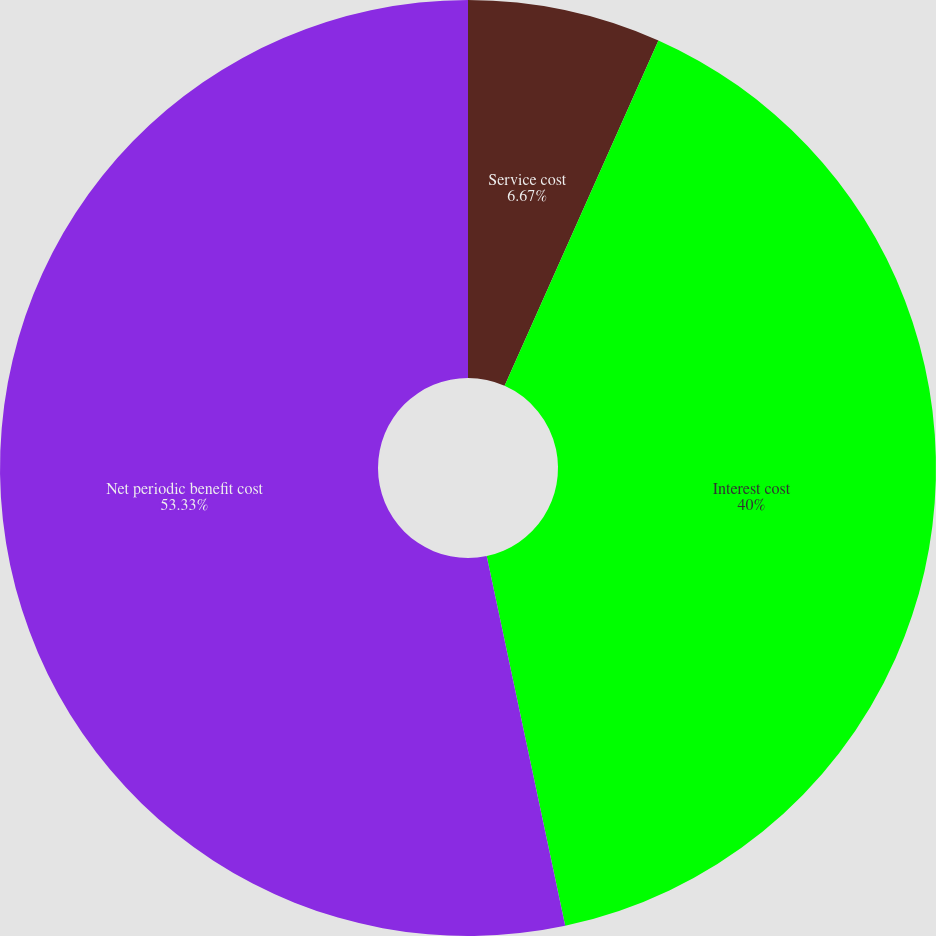Convert chart to OTSL. <chart><loc_0><loc_0><loc_500><loc_500><pie_chart><fcel>Service cost<fcel>Interest cost<fcel>Net periodic benefit cost<nl><fcel>6.67%<fcel>40.0%<fcel>53.33%<nl></chart> 